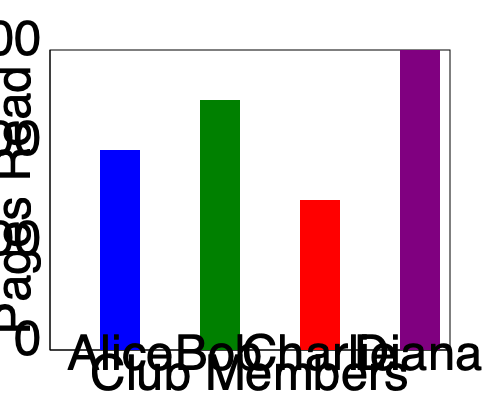As the organizer of the virtual book club, you're analyzing the reading progress of your members. Based on the bar graph showing the number of pages read by different club members, who has read the most pages, and how many more pages have they read compared to the member who has read the least? To answer this question, we need to follow these steps:

1. Identify the number of pages read by each member:
   - Alice (blue bar): 200 pages
   - Bob (green bar): 250 pages
   - Charlie (red bar): 150 pages
   - Diana (purple bar): 300 pages

2. Determine who has read the most pages:
   Diana has read the most with 300 pages.

3. Determine who has read the least pages:
   Charlie has read the least with 150 pages.

4. Calculate the difference between the highest and lowest:
   $300 - 150 = 150$ pages

Therefore, Diana has read the most pages, and she has read 150 more pages than Charlie, who has read the least.
Answer: Diana; 150 pages 